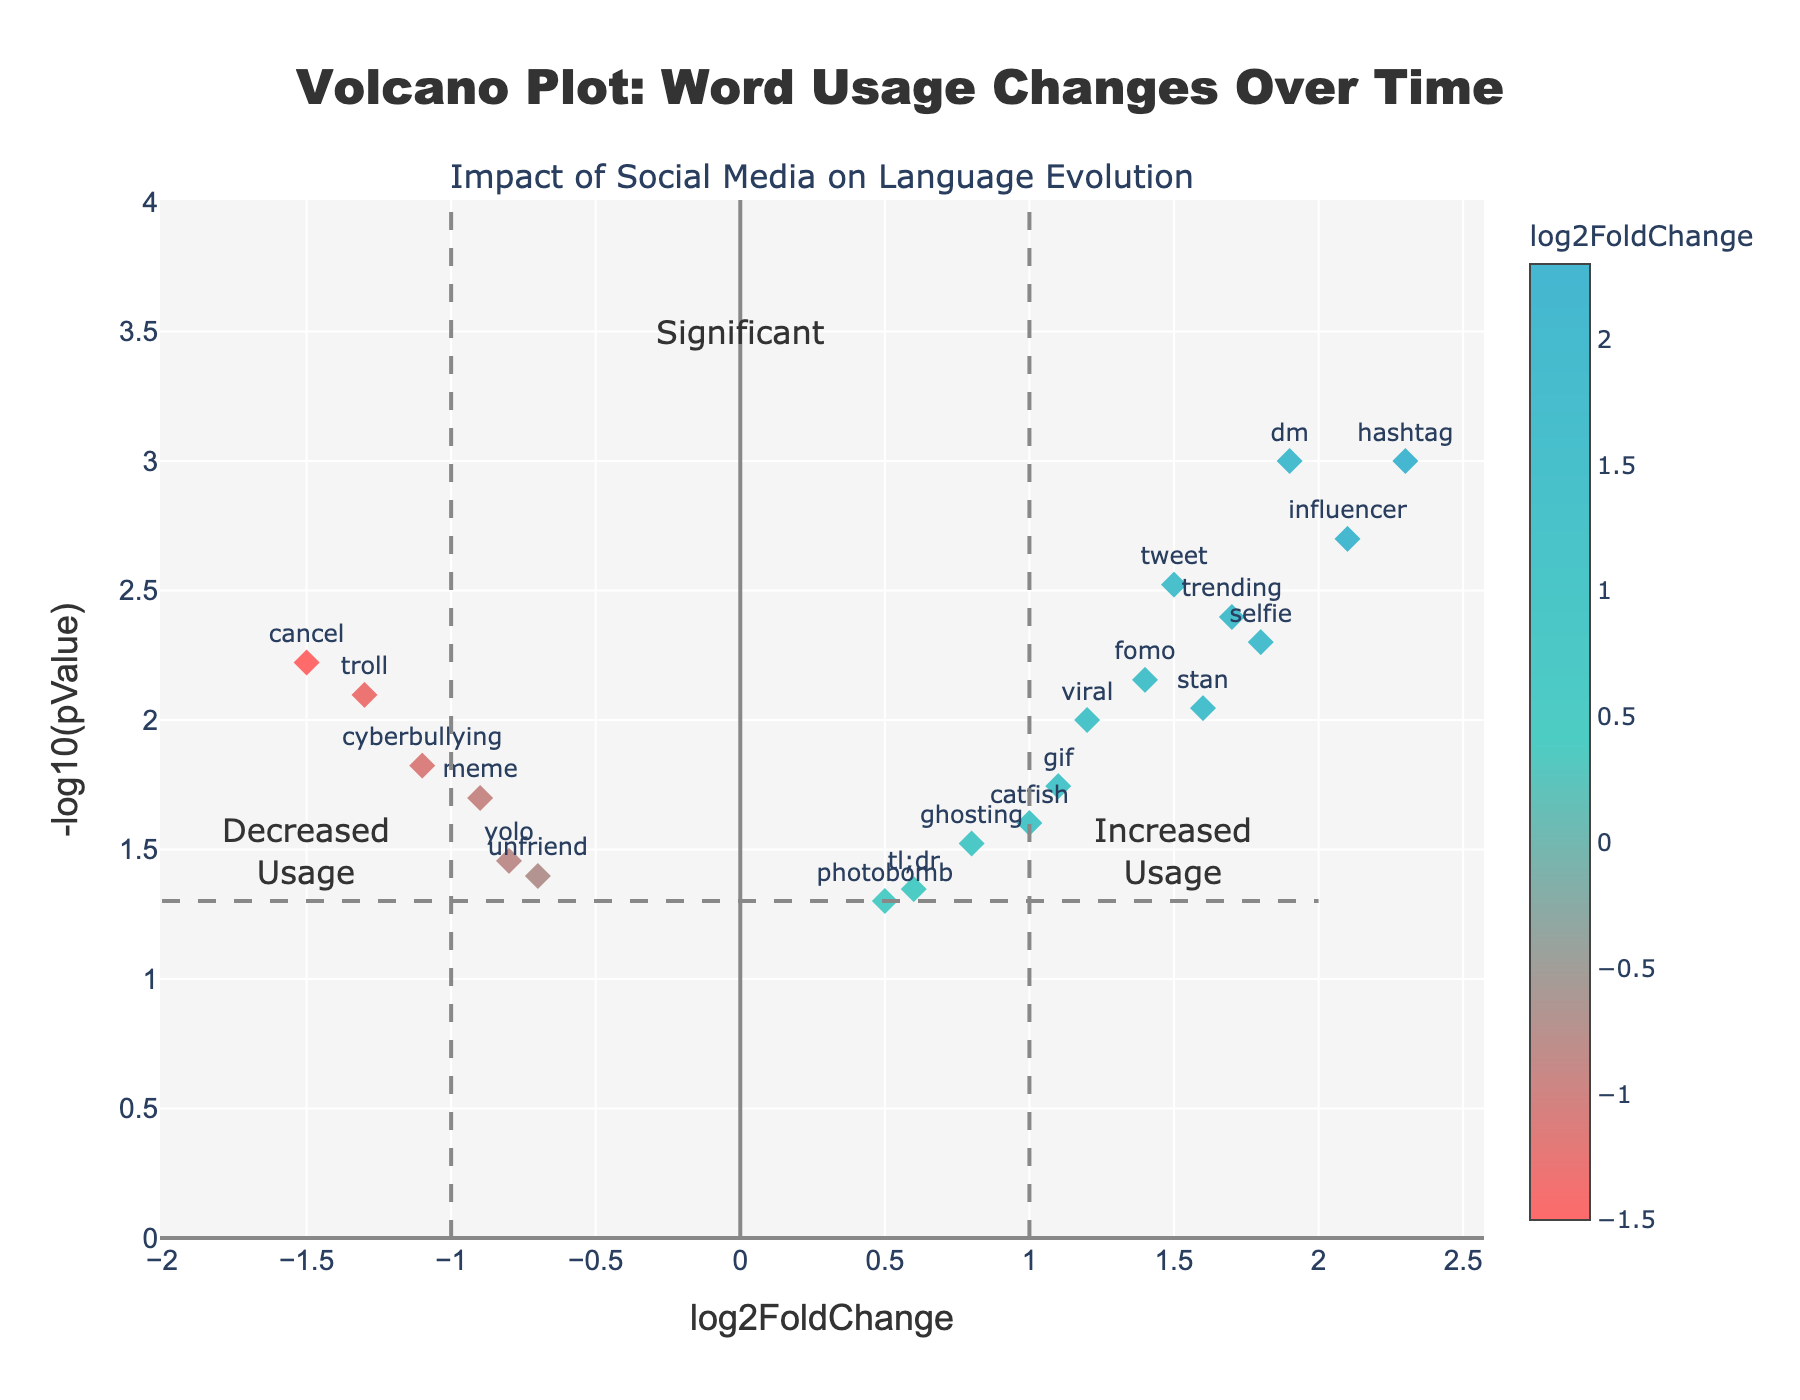what is the title of the plot? The title is usually at the top of the plot. It reads 'Volcano Plot: Word Usage Changes Over Time'.
Answer: Volcano Plot: Word Usage Changes Over Time what are the axes labels in the plot? The x-axis label is 'log2FoldChange', and the y-axis label is '-log10(pValue)'. These labels are typically used in volcano plots to depict fold change and statistical significance.
Answer: log2FoldChange and -log10(pValue) how many words have significantly increased in usage? Words with significant increases have a log2FoldChange greater than 1 and a -log10(pValue) above 1.3 (p-value < 0.05). These words are 'hashtag', 'selfie', 'tweet', 'influencer', 'trending', 'dm', 'fomo', 'stan', and 'gif'.
Answer: 9 which word has the highest log2FoldChange value? By looking at the x-axis, the point farthest to the right represents the highest log2FoldChange. The word at this point is 'hashtag' with a log2FoldChange of 2.3.
Answer: hashtag how many words have a decrease in usage with statistical significance? Words with a significant decrease in usage have a log2FoldChange less than -1 and a -log10(pValue) above 1.3 (p-value < 0.05). These words are 'troll', 'cyberbullying', and 'cancel'.
Answer: 3 which two words have a similar log2FoldChange value but differ in statistical significance? Words with similar x-axis (log2FoldChange) but different y-axis (-log10(pValue)) values are 'tweet' and 'trending'. 'Tweet' has a higher -log10(pValue) compared to 'trending'.
Answer: tweet and trending what is the p-value for the word 'selfie'? The plot hover text might show p-values directly. The p-value for 'selfie' according to the hover text is 0.005.
Answer: 0.005 which word had the largest decrease in usage? The point farthest to the left on the x-axis correlates with the largest negative log2FoldChange. The word at this point is 'cancel' with a log2FoldChange of -1.5.
Answer: cancel identify the approximate log2FoldChange and -log10(pValue) for the word 'ghosting'. By locating 'ghosting' on the plot, we see it's approximately at log2FoldChange 0.8 and -log10(pValue) 1.52.
Answer: 0.8 and 1.52 